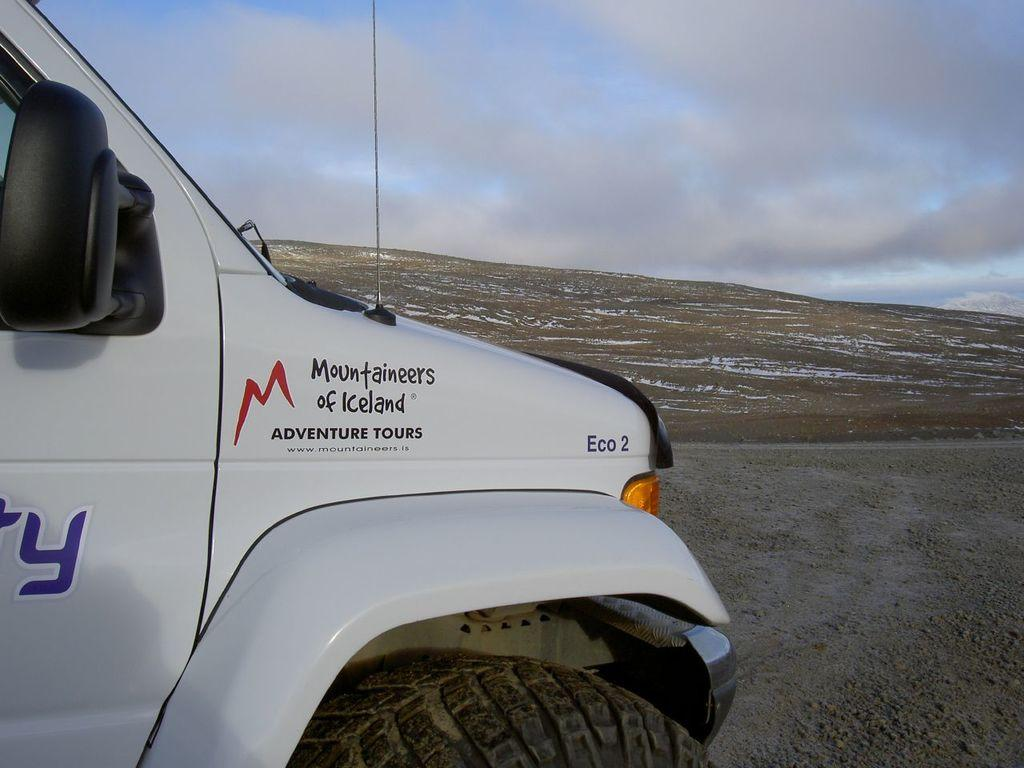What is the main subject of the image? There is a car in the image. What is the condition of the surface in the image? Snow is present on the surface in the image. What can be seen in the background of the image? The sky is visible in the background of the image. How many legs can be seen supporting the car in the image? There are no legs visible in the image; the car is resting on the snow-covered surface. 